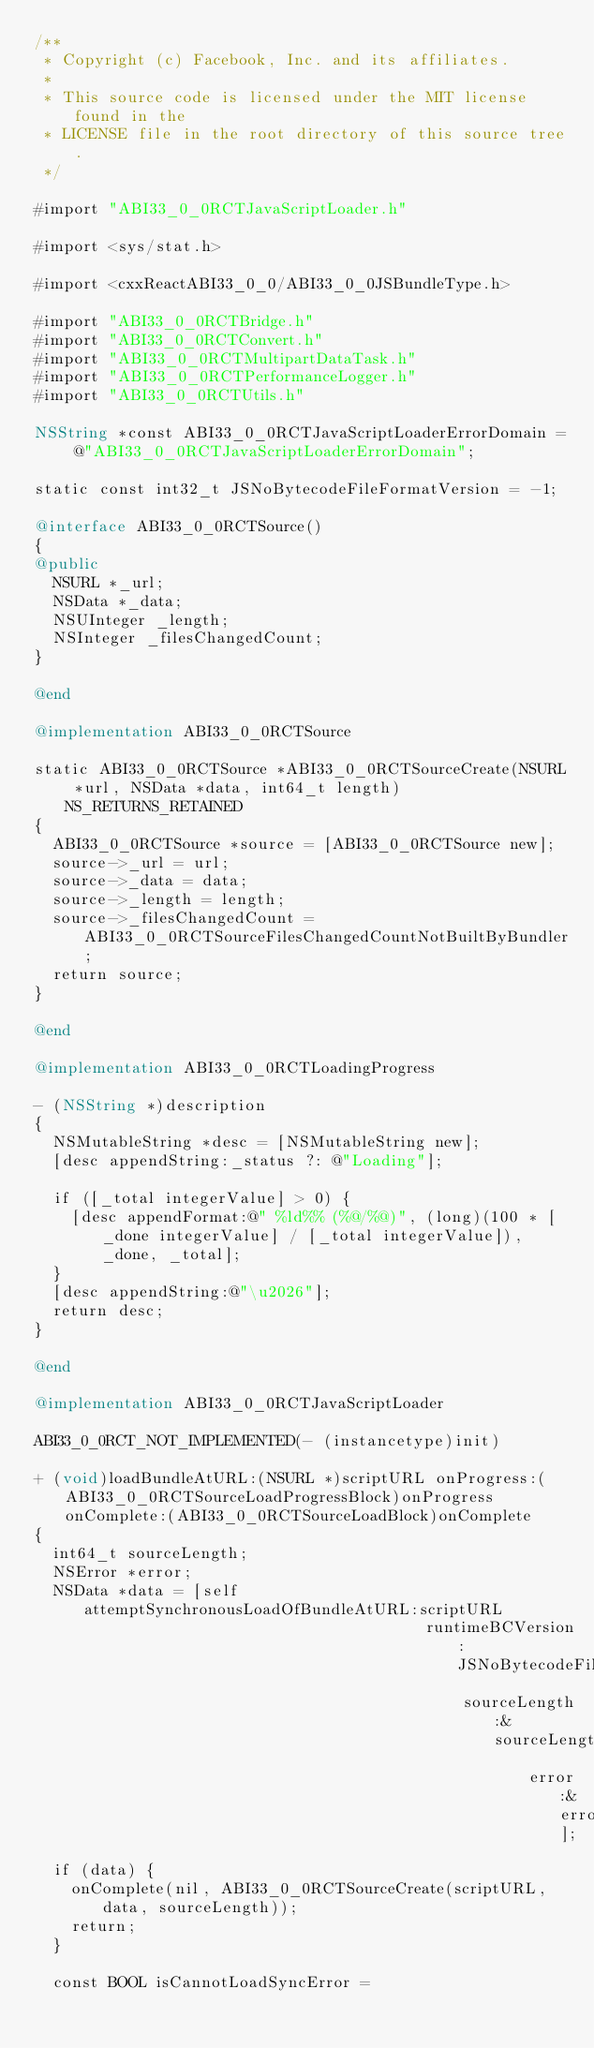Convert code to text. <code><loc_0><loc_0><loc_500><loc_500><_ObjectiveC_>/**
 * Copyright (c) Facebook, Inc. and its affiliates.
 *
 * This source code is licensed under the MIT license found in the
 * LICENSE file in the root directory of this source tree.
 */

#import "ABI33_0_0RCTJavaScriptLoader.h"

#import <sys/stat.h>

#import <cxxReactABI33_0_0/ABI33_0_0JSBundleType.h>

#import "ABI33_0_0RCTBridge.h"
#import "ABI33_0_0RCTConvert.h"
#import "ABI33_0_0RCTMultipartDataTask.h"
#import "ABI33_0_0RCTPerformanceLogger.h"
#import "ABI33_0_0RCTUtils.h"

NSString *const ABI33_0_0RCTJavaScriptLoaderErrorDomain = @"ABI33_0_0RCTJavaScriptLoaderErrorDomain";

static const int32_t JSNoBytecodeFileFormatVersion = -1;

@interface ABI33_0_0RCTSource()
{
@public
  NSURL *_url;
  NSData *_data;
  NSUInteger _length;
  NSInteger _filesChangedCount;
}

@end

@implementation ABI33_0_0RCTSource

static ABI33_0_0RCTSource *ABI33_0_0RCTSourceCreate(NSURL *url, NSData *data, int64_t length) NS_RETURNS_RETAINED
{
  ABI33_0_0RCTSource *source = [ABI33_0_0RCTSource new];
  source->_url = url;
  source->_data = data;
  source->_length = length;
  source->_filesChangedCount = ABI33_0_0RCTSourceFilesChangedCountNotBuiltByBundler;
  return source;
}

@end

@implementation ABI33_0_0RCTLoadingProgress

- (NSString *)description
{
  NSMutableString *desc = [NSMutableString new];
  [desc appendString:_status ?: @"Loading"];

  if ([_total integerValue] > 0) {
    [desc appendFormat:@" %ld%% (%@/%@)", (long)(100 * [_done integerValue] / [_total integerValue]), _done, _total];
  }
  [desc appendString:@"\u2026"];
  return desc;
}

@end

@implementation ABI33_0_0RCTJavaScriptLoader

ABI33_0_0RCT_NOT_IMPLEMENTED(- (instancetype)init)

+ (void)loadBundleAtURL:(NSURL *)scriptURL onProgress:(ABI33_0_0RCTSourceLoadProgressBlock)onProgress onComplete:(ABI33_0_0RCTSourceLoadBlock)onComplete
{
  int64_t sourceLength;
  NSError *error;
  NSData *data = [self attemptSynchronousLoadOfBundleAtURL:scriptURL
                                          runtimeBCVersion:JSNoBytecodeFileFormatVersion
                                              sourceLength:&sourceLength
                                                     error:&error];
  if (data) {
    onComplete(nil, ABI33_0_0RCTSourceCreate(scriptURL, data, sourceLength));
    return;
  }

  const BOOL isCannotLoadSyncError =</code> 